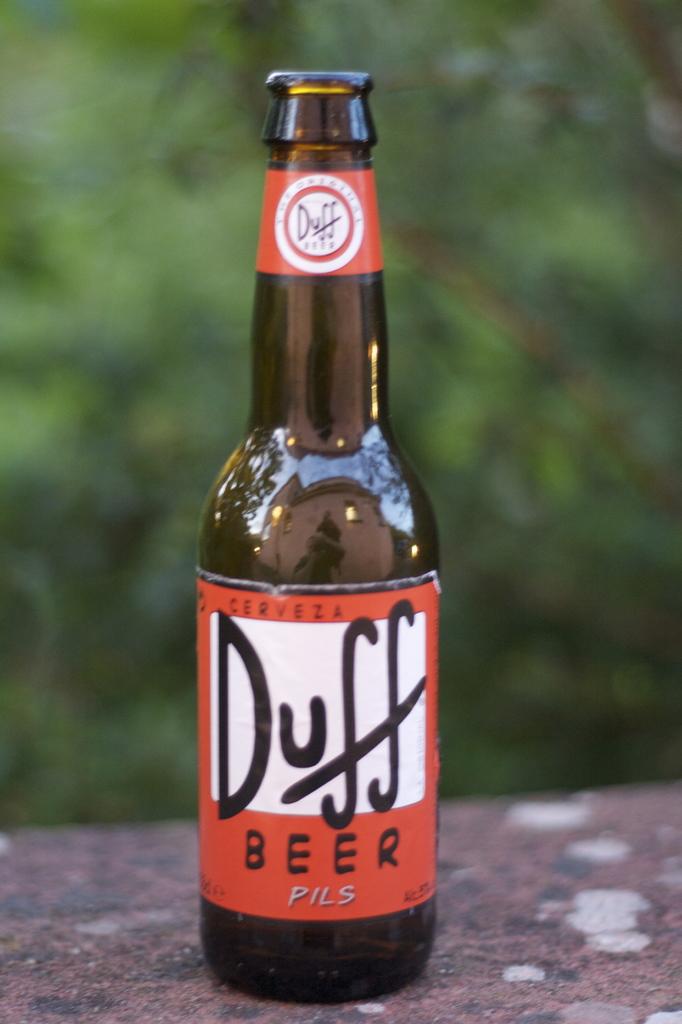What beer is this?
Provide a succinct answer. Duff. What type of beer is this?
Your answer should be compact. Duff. 